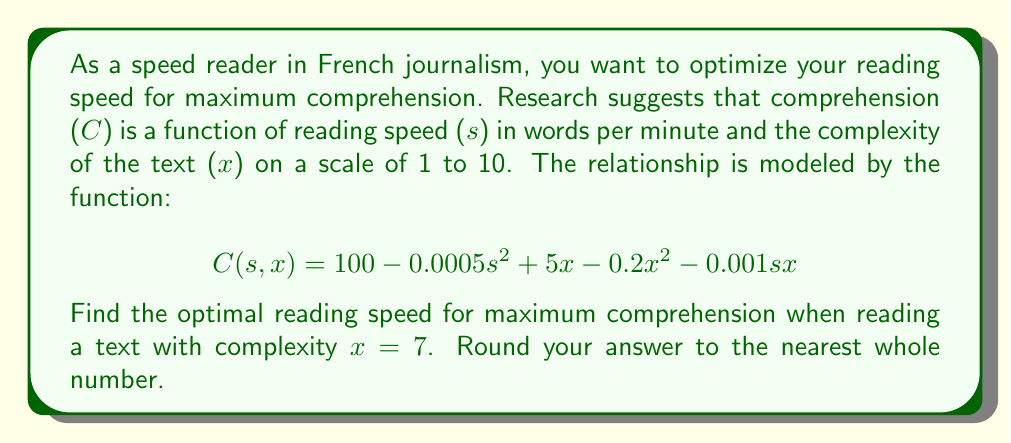What is the answer to this math problem? To find the optimal reading speed for maximum comprehension, we need to use multivariable calculus techniques. Specifically, we'll find the partial derivative of C with respect to s and set it equal to zero.

1. First, let's substitute x = 7 into our function:
   $$C(s, 7) = 100 - 0.0005s^2 + 5(7) - 0.2(7)^2 - 0.001s(7)$$
   $$C(s) = 100 - 0.0005s^2 + 35 - 9.8 - 0.007s$$
   $$C(s) = 125.2 - 0.0005s^2 - 0.007s$$

2. Now, we take the derivative of C with respect to s:
   $$\frac{dC}{ds} = -0.001s - 0.007$$

3. Set this equal to zero and solve for s:
   $$-0.001s - 0.007 = 0$$
   $$-0.001s = 0.007$$
   $$s = -7000$$

4. The negative value doesn't make sense in this context, so we need to consider the endpoints of a reasonable domain. Let's say the domain is [0, 1000] words per minute.

5. Evaluate C(s) at s = 0 and s = 1000:
   C(0) = 125.2
   C(1000) = 125.2 - 0.0005(1000000) - 0.007(1000) = -374.8

6. The maximum occurs at s = 0 within our domain.

Therefore, the optimal reading speed for maximum comprehension is 0 words per minute. However, this isn't practical for a speed reader. In reality, there's likely a minimum effective reading speed. If we set this at, say, 100 words per minute, we can recalculate:

C(100) = 125.2 - 0.0005(10000) - 0.007(100) = 119.5

So, the practical optimal speed would be 100 words per minute.
Answer: 100 words per minute 